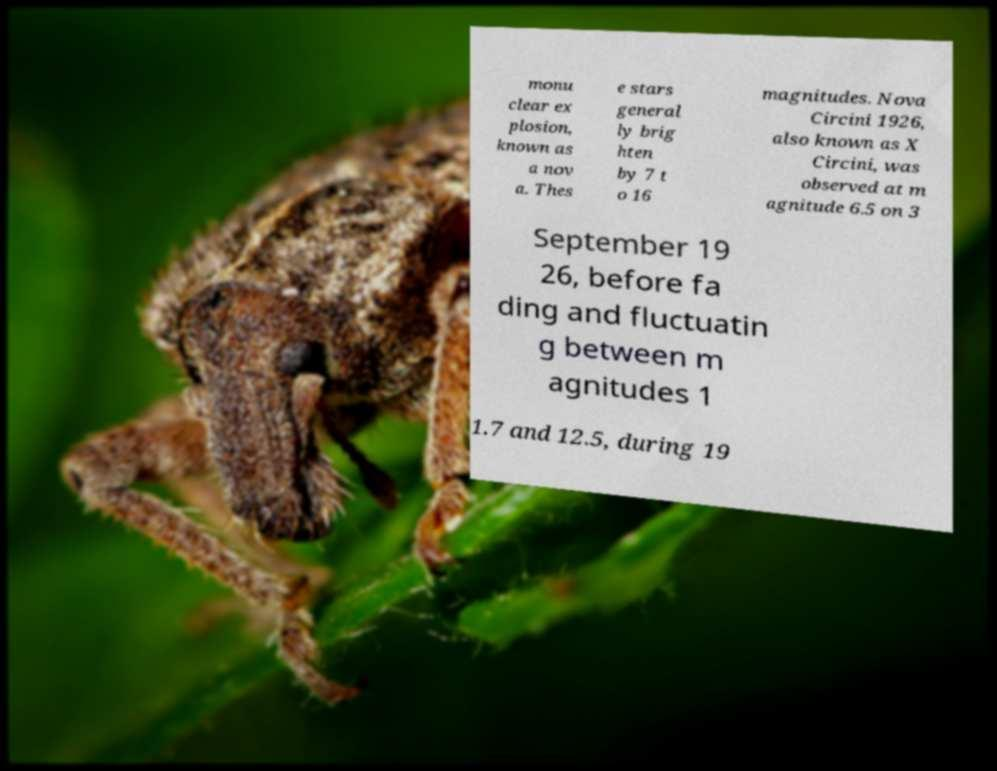There's text embedded in this image that I need extracted. Can you transcribe it verbatim? monu clear ex plosion, known as a nov a. Thes e stars general ly brig hten by 7 t o 16 magnitudes. Nova Circini 1926, also known as X Circini, was observed at m agnitude 6.5 on 3 September 19 26, before fa ding and fluctuatin g between m agnitudes 1 1.7 and 12.5, during 19 